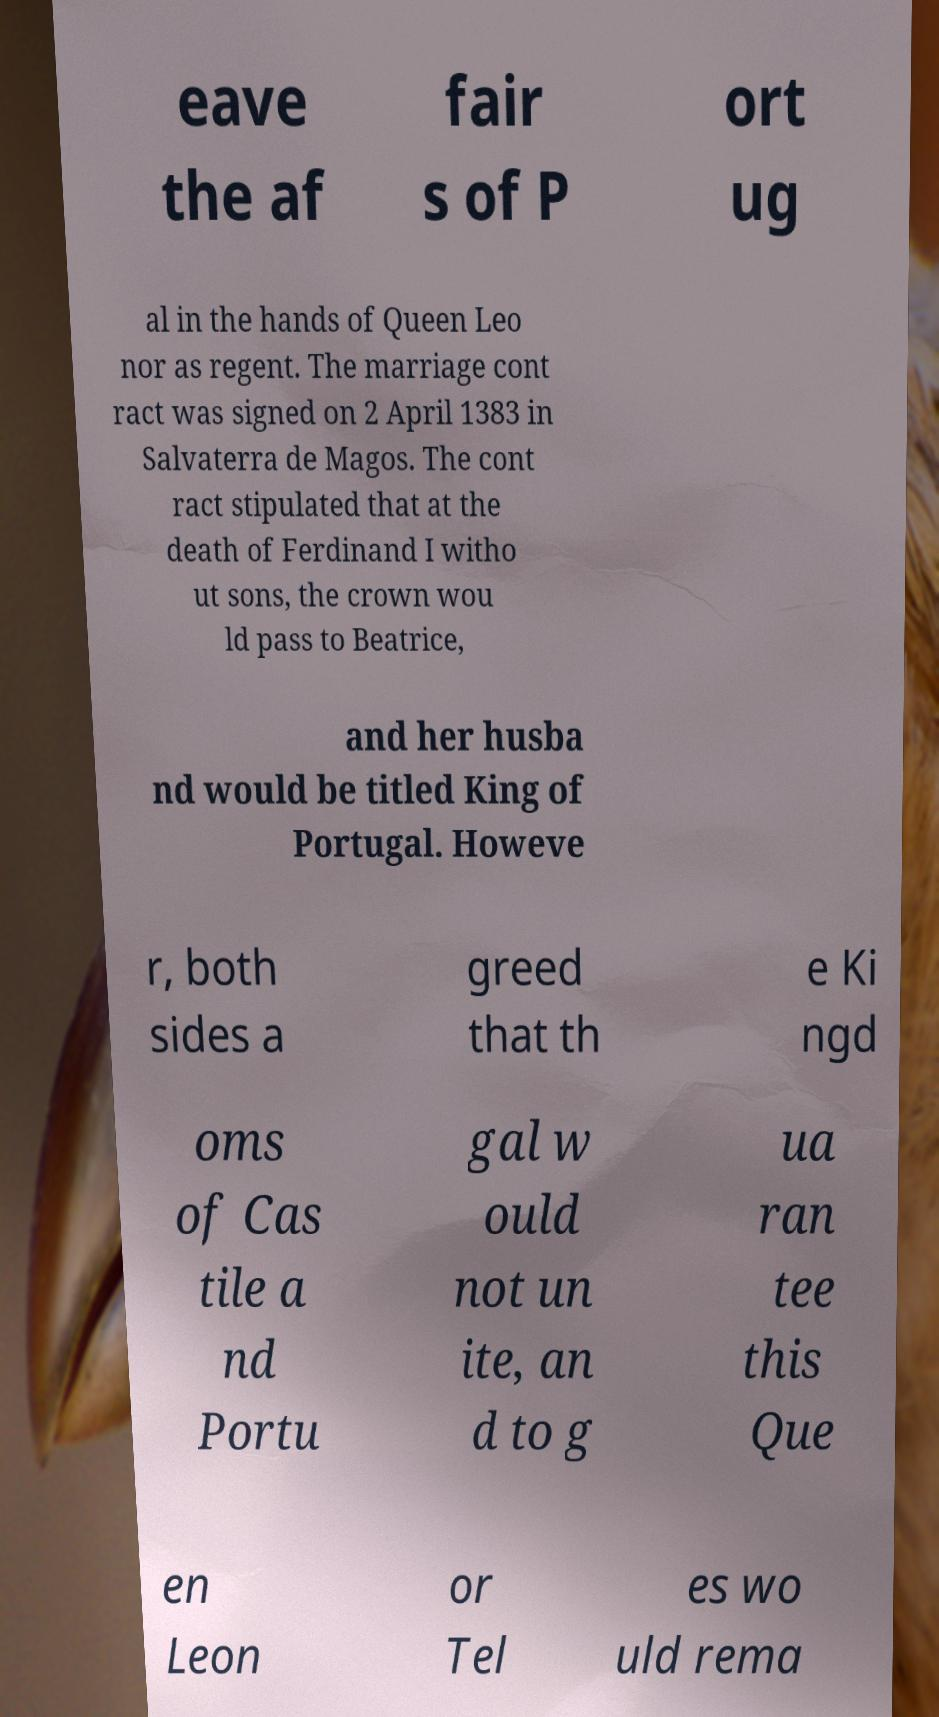Can you accurately transcribe the text from the provided image for me? eave the af fair s of P ort ug al in the hands of Queen Leo nor as regent. The marriage cont ract was signed on 2 April 1383 in Salvaterra de Magos. The cont ract stipulated that at the death of Ferdinand I witho ut sons, the crown wou ld pass to Beatrice, and her husba nd would be titled King of Portugal. Howeve r, both sides a greed that th e Ki ngd oms of Cas tile a nd Portu gal w ould not un ite, an d to g ua ran tee this Que en Leon or Tel es wo uld rema 